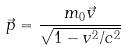<formula> <loc_0><loc_0><loc_500><loc_500>\vec { p } = \frac { m _ { 0 } \vec { v } } { \sqrt { 1 - v ^ { 2 } / c ^ { 2 } } }</formula> 